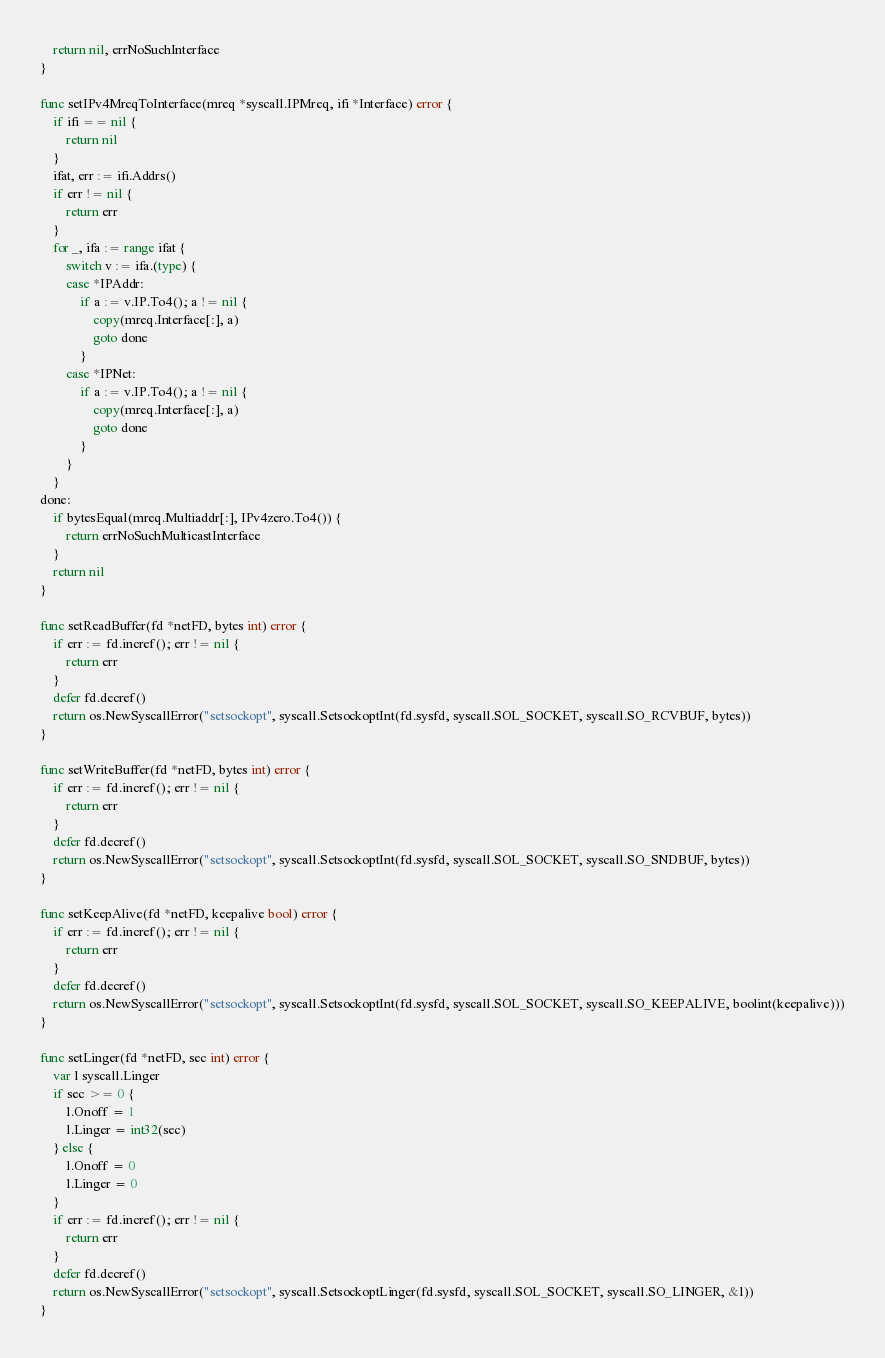Convert code to text. <code><loc_0><loc_0><loc_500><loc_500><_Go_>	return nil, errNoSuchInterface
}

func setIPv4MreqToInterface(mreq *syscall.IPMreq, ifi *Interface) error {
	if ifi == nil {
		return nil
	}
	ifat, err := ifi.Addrs()
	if err != nil {
		return err
	}
	for _, ifa := range ifat {
		switch v := ifa.(type) {
		case *IPAddr:
			if a := v.IP.To4(); a != nil {
				copy(mreq.Interface[:], a)
				goto done
			}
		case *IPNet:
			if a := v.IP.To4(); a != nil {
				copy(mreq.Interface[:], a)
				goto done
			}
		}
	}
done:
	if bytesEqual(mreq.Multiaddr[:], IPv4zero.To4()) {
		return errNoSuchMulticastInterface
	}
	return nil
}

func setReadBuffer(fd *netFD, bytes int) error {
	if err := fd.incref(); err != nil {
		return err
	}
	defer fd.decref()
	return os.NewSyscallError("setsockopt", syscall.SetsockoptInt(fd.sysfd, syscall.SOL_SOCKET, syscall.SO_RCVBUF, bytes))
}

func setWriteBuffer(fd *netFD, bytes int) error {
	if err := fd.incref(); err != nil {
		return err
	}
	defer fd.decref()
	return os.NewSyscallError("setsockopt", syscall.SetsockoptInt(fd.sysfd, syscall.SOL_SOCKET, syscall.SO_SNDBUF, bytes))
}

func setKeepAlive(fd *netFD, keepalive bool) error {
	if err := fd.incref(); err != nil {
		return err
	}
	defer fd.decref()
	return os.NewSyscallError("setsockopt", syscall.SetsockoptInt(fd.sysfd, syscall.SOL_SOCKET, syscall.SO_KEEPALIVE, boolint(keepalive)))
}

func setLinger(fd *netFD, sec int) error {
	var l syscall.Linger
	if sec >= 0 {
		l.Onoff = 1
		l.Linger = int32(sec)
	} else {
		l.Onoff = 0
		l.Linger = 0
	}
	if err := fd.incref(); err != nil {
		return err
	}
	defer fd.decref()
	return os.NewSyscallError("setsockopt", syscall.SetsockoptLinger(fd.sysfd, syscall.SOL_SOCKET, syscall.SO_LINGER, &l))
}
</code> 